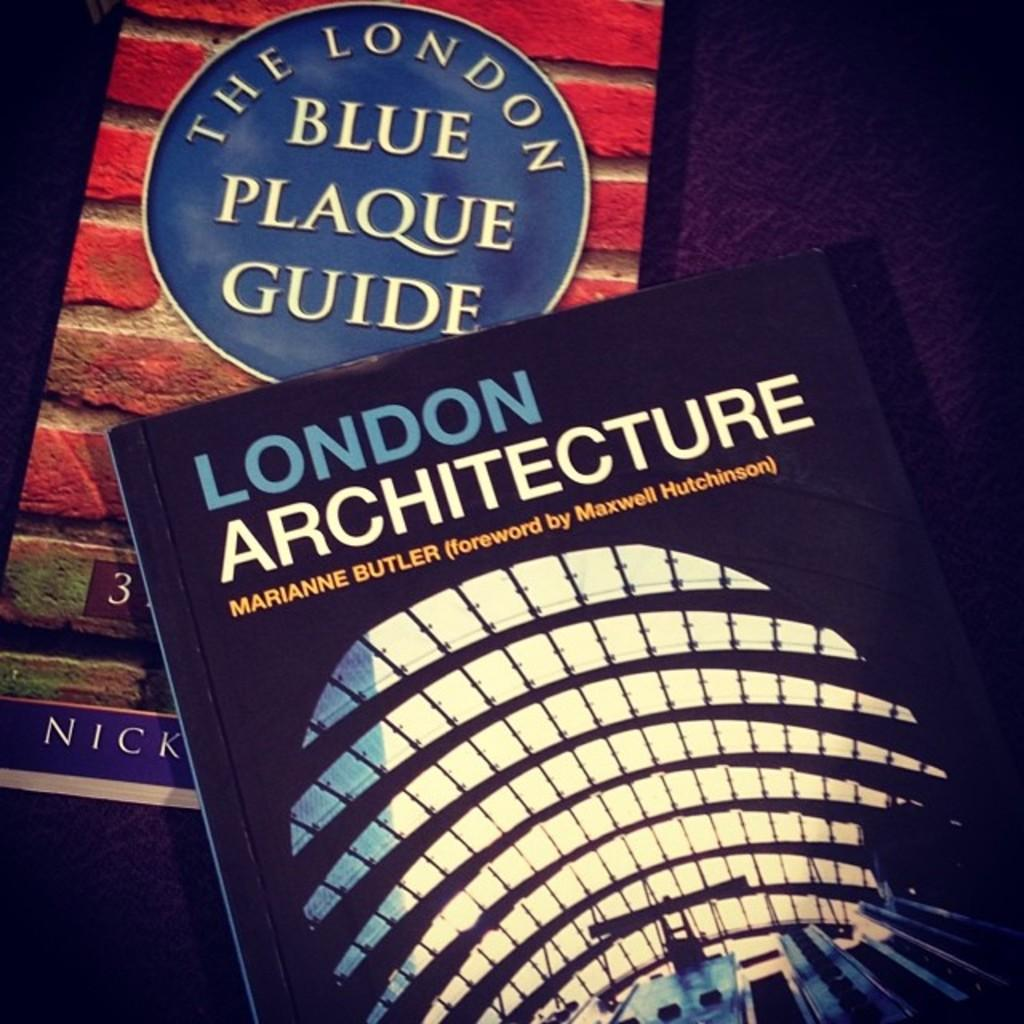<image>
Present a compact description of the photo's key features. Two books with the one on top being for London architecture. 